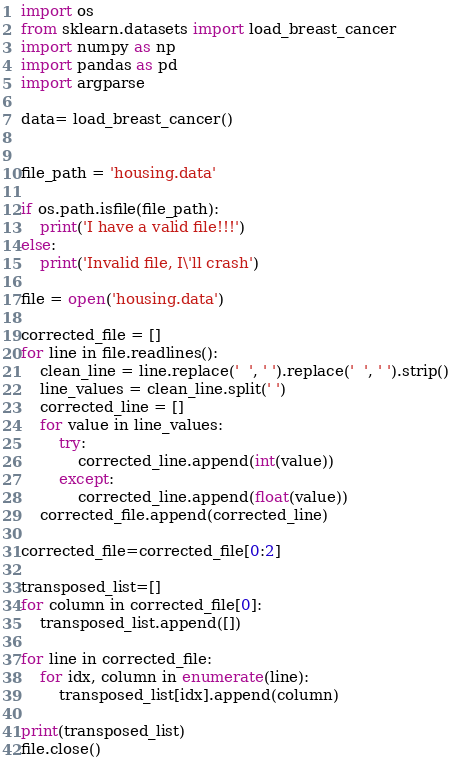<code> <loc_0><loc_0><loc_500><loc_500><_Python_>import os
from sklearn.datasets import load_breast_cancer
import numpy as np
import pandas as pd
import argparse

data= load_breast_cancer()


file_path = 'housing.data'

if os.path.isfile(file_path):
    print('I have a valid file!!!')
else:
    print('Invalid file, I\'ll crash')

file = open('housing.data')

corrected_file = []
for line in file.readlines():
    clean_line = line.replace('  ', ' ').replace('  ', ' ').strip()
    line_values = clean_line.split(' ')
    corrected_line = []
    for value in line_values:
        try:
            corrected_line.append(int(value))
        except:
            corrected_line.append(float(value))
    corrected_file.append(corrected_line)

corrected_file=corrected_file[0:2]

transposed_list=[]
for column in corrected_file[0]:
    transposed_list.append([])

for line in corrected_file:
    for idx, column in enumerate(line):
        transposed_list[idx].append(column)

print(transposed_list)
file.close()
</code> 